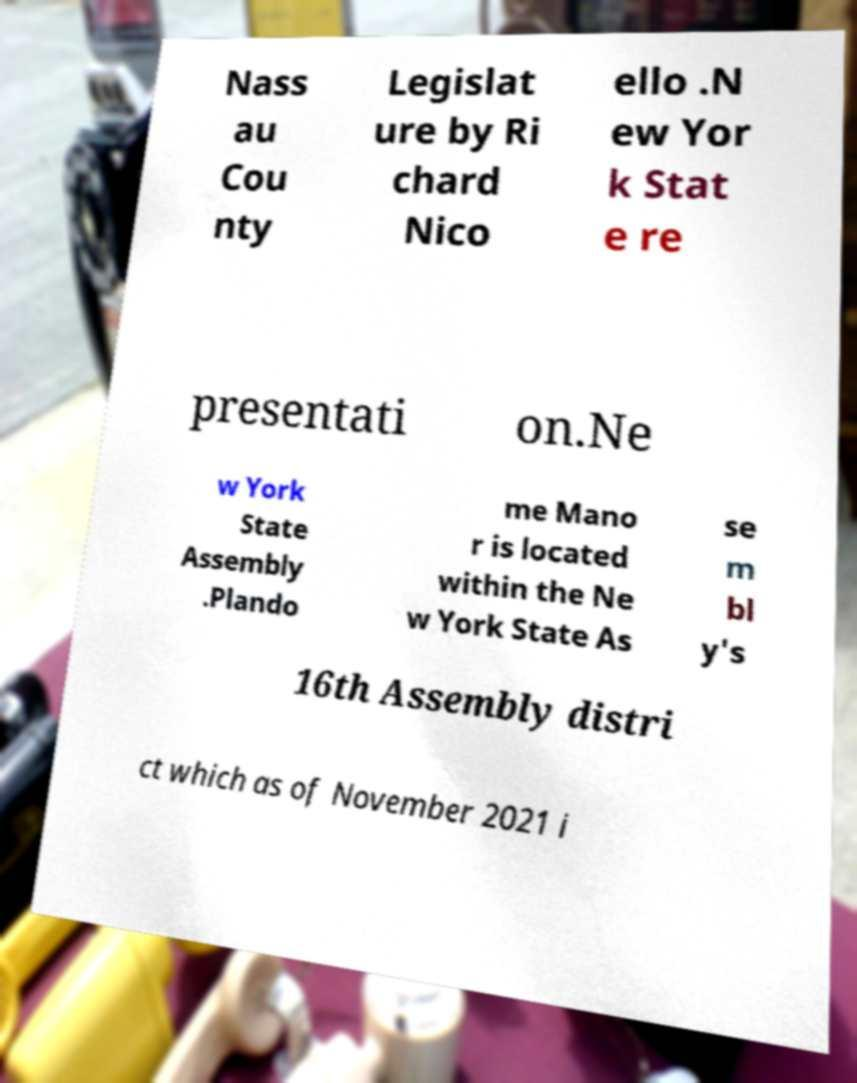Can you accurately transcribe the text from the provided image for me? Nass au Cou nty Legislat ure by Ri chard Nico ello .N ew Yor k Stat e re presentati on.Ne w York State Assembly .Plando me Mano r is located within the Ne w York State As se m bl y's 16th Assembly distri ct which as of November 2021 i 